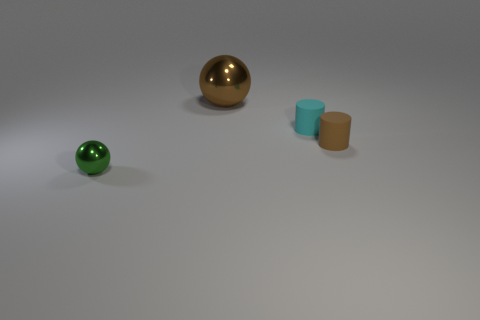There is a metallic thing in front of the brown rubber cylinder; what is its shape?
Ensure brevity in your answer.  Sphere. There is a metallic object that is right of the object left of the sphere to the right of the small green ball; what is its size?
Offer a terse response. Large. Is the green metal thing the same shape as the small cyan rubber object?
Provide a short and direct response. No. What is the size of the thing that is both in front of the small cyan cylinder and left of the cyan cylinder?
Make the answer very short. Small. There is a tiny cyan thing that is the same shape as the brown rubber thing; what is it made of?
Your answer should be compact. Rubber. The ball that is behind the metal sphere that is on the left side of the big brown sphere is made of what material?
Provide a succinct answer. Metal. There is a small cyan matte object; is its shape the same as the metal thing left of the big thing?
Your answer should be compact. No. How many shiny objects are either large things or brown cylinders?
Give a very brief answer. 1. What is the color of the metallic object that is right of the ball that is on the left side of the sphere that is behind the small green shiny sphere?
Provide a succinct answer. Brown. How many other things are the same material as the green thing?
Give a very brief answer. 1. 